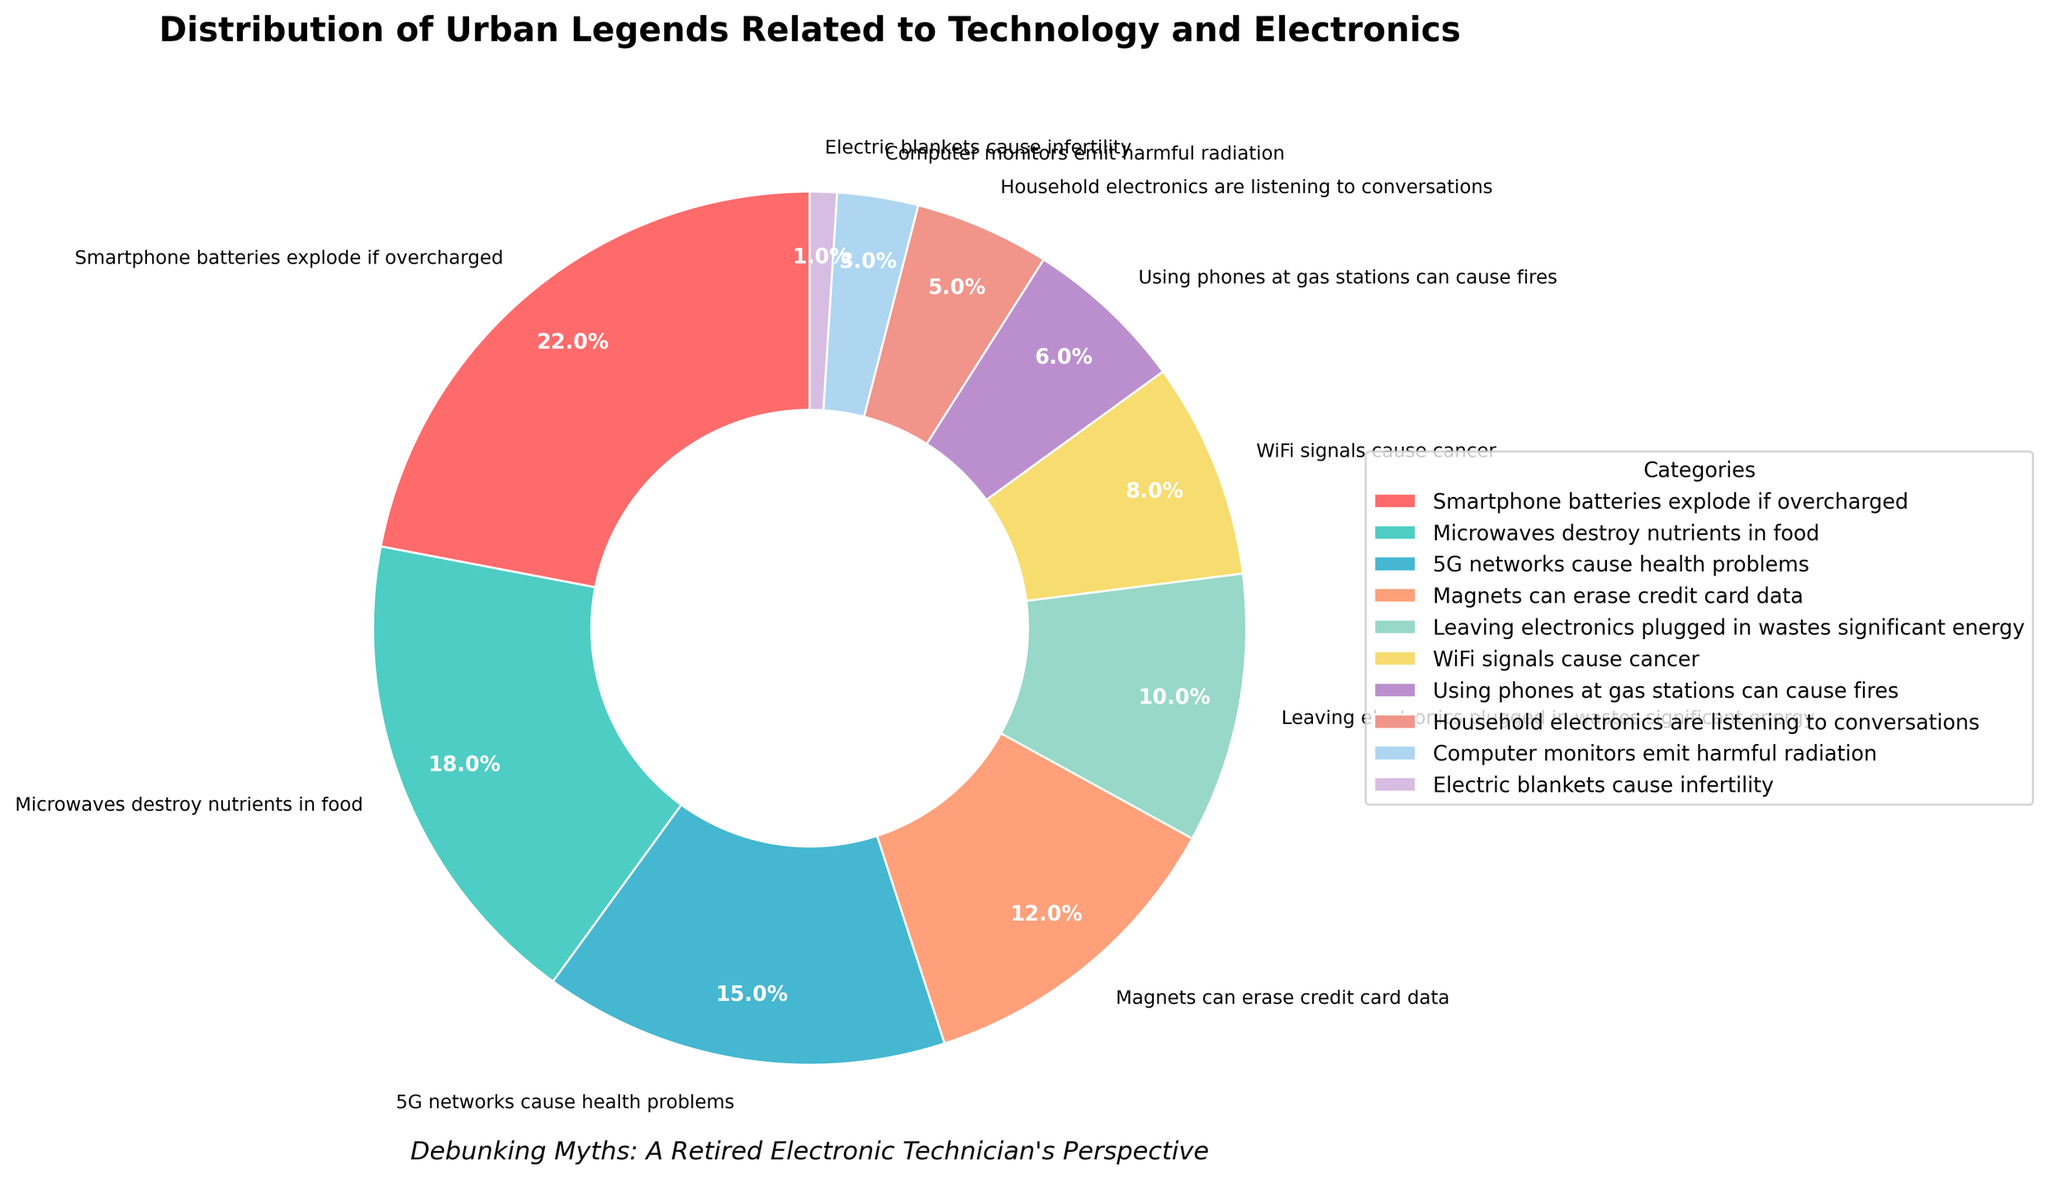What's the most prevalent urban legend about technology and electronics in the pie chart? The figure has multiple sections, each representing a different urban legend about technology and electronics. The largest section, which is colored red, corresponds to the legend "Smartphone batteries explode if overcharged" constituting 22% of the total.
Answer: "Smartphone batteries explode if overcharged" Which urban legend related to technology and electronics is the least prevalent? By examining the smallest section of the pie chart, which is colored purple, it represents the legend "Electric blankets cause infertility". This section has the smallest percentage in comparison to others at 1%.
Answer: "Electric blankets cause infertility" What is the combined percentage of urban legends concerning health problems caused by technology? Identify the segments related to health problems: "Microwaves destroy nutrients in food" (18%), "5G networks cause health problems" (15%), and "WiFi signals cause cancer" (8%). Adding these values together results in a combined percentage of 18% + 15% + 8% = 41%.
Answer: 41% Which urban legend is more prevalent: "Using phones at gas stations can cause fires" or "Computer monitors emit harmful radiation"? Examine both sections, "Using phones at gas stations can cause fires" is colored in light red with a percentage of 6%, while "Computer monitors emit harmful radiation" is colored in light purple with a percentage of 3%. Therefore, "Using phones at gas stations can cause fires" is more prevalent.
Answer: "Using phones at gas stations can cause fires" How does the percentage of legends involving energy consumption compare to those involving eavesdropping or privacy issues? Identify the relevant segments: "Leaving electronics plugged in wastes significant energy" (10%) and "Household electronics are listening to conversations" (5%). Comparing these two, the energy consumption legend (10%) is twice as prevalent as the eavesdropping legend (5%).
Answer: Energy consumption legends are twice as prevalent Of the top three urban legends by prevalence, which color represents each in the pie chart? The top three legends by prevalence are "Smartphone batteries explode if overcharged" (22%), "Microwaves destroy nutrients in food" (18%), and "5G networks cause health problems" (15%). The colors representing them are red for "Smartphone batteries explode if overcharged", greenish-blue for "Microwaves destroy nutrients in food", and blue for "5G networks cause health problems".
Answer: Red, greenish-blue, and blue respectively What is the average percentage of the bottom five least prevalent urban legends? Identify the bottom five least prevalent urban legends: "Electric blankets cause infertility" (1%), "Computer monitors emit harmful radiation" (3%), "Household electronics are listening to conversations" (5%), "Using phones at gas stations can cause fires" (6%), "WiFi signals cause cancer" (8%). Sum these values and divide by five to get the average: (1+3+5+6+8)/5 = 4.6%.
Answer: 4.6% Which legend has a percentage closest to the combined percentage of "Microwaves destroy nutrients in food" and "Household electronics are listening to conversations"? First, combine the percentages of "Microwaves destroy nutrients in food" (18%) and "Household electronics are listening to conversations" (5%): 18% + 5% = 23%. The legend closest to 23% is "Smartphone batteries explode if overcharged" at 22%.
Answer: "Smartphone batteries explode if overcharged" What is the difference in percentage between the second most common and the second least common urban legends? The second most common urban legend is "Microwaves destroy nutrients in food" at 18%, and the second least common one is "Computer monitors emit harmful radiation" at 3%. The difference is 18% - 3% = 15%.
Answer: 15% Which legend has a percentage that is exactly half of the most prevalent one? The most prevalent legend is "Smartphone batteries explode if overcharged" at 22%. Half of 22% is 11%. There is no legend with a percentage of exactly 11%. The closest ones are "Magnets can erase credit card data" (12%) and "Leaving electronics plugged in wastes significant energy" (10%). However, none match exactly 11%.
Answer: None 